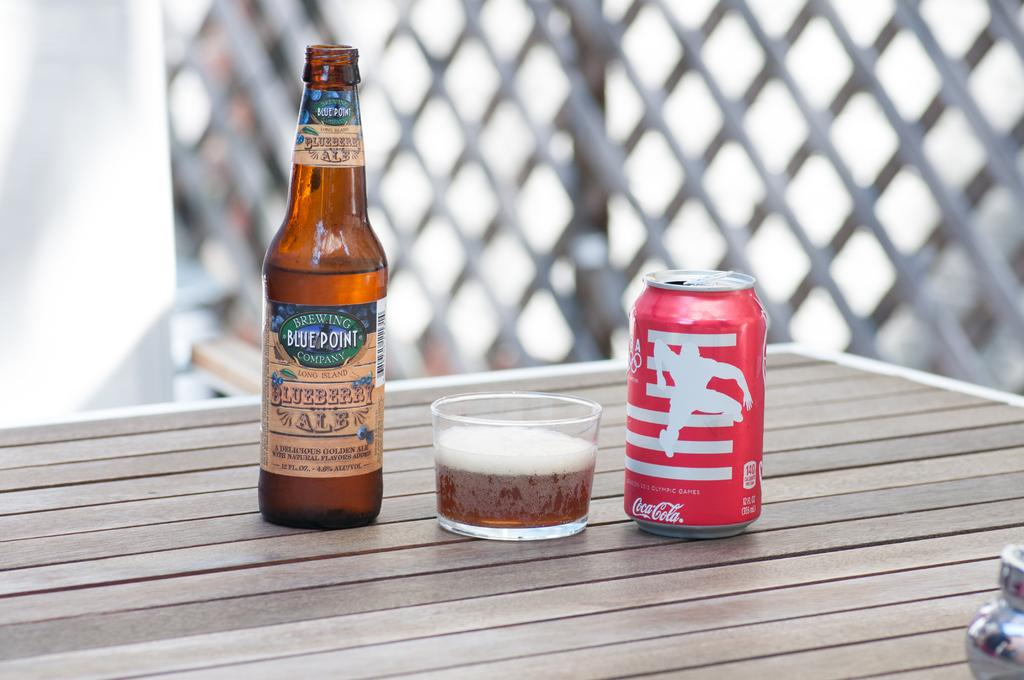<image>
Summarize the visual content of the image. A bottle from the Blue Point Brewing Company is next to a glass and a red can. 